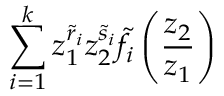<formula> <loc_0><loc_0><loc_500><loc_500>\sum _ { i = 1 } ^ { k } z _ { 1 } ^ { \tilde { r } _ { i } } z _ { 2 } ^ { \tilde { s } _ { i } } \tilde { f } _ { i } \left ( \frac { z _ { 2 } } { z _ { 1 } } \right )</formula> 